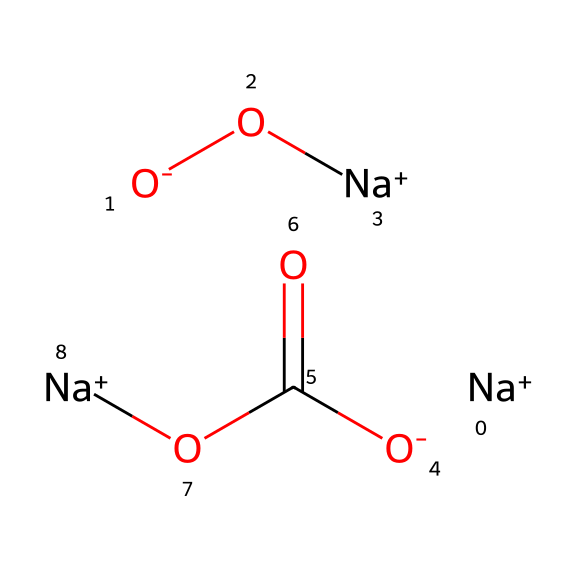what is the total number of sodium atoms in the chemical? By examining the SMILES representation, there are three occurrences of the sodium ion (Na+) present. Each Na+ indicates one sodium atom.
Answer: three how many oxygen atoms are present in the molecule? The SMILES contains four instances of "O", and there’s one "O-" which counts as one additional oxygen. When summing these, we find a total of 6 oxygen atoms.
Answer: six what is the primary role of sodium percarbonate in the context of laundry? Sodium percarbonate acts as an oxidizing agent, which helps in breaking down stains and whitening fabrics by releasing hydrogen peroxide in water.
Answer: oxidizing agent which part of the molecule contributes to its oxidizing properties? The percarbonate part, specifically the structure (C(=O)O) which, when dissolved, decomposes to release oxygen and has oxidizing abilities.
Answer: percarbonate what type of chemical compound is sodium percarbonate classified as? Sodium percarbonate is classified as an inorganic compound and more specifically as a peroxide due to the presence of the percarbonate group which generates reactive oxygen species.
Answer: peroxide does sodium percarbonate contain any acidic groups? Yes, the carbonic acid moiety (C(=O)O) is part of the molecule, indicating the presence of acidic character.
Answer: yes 